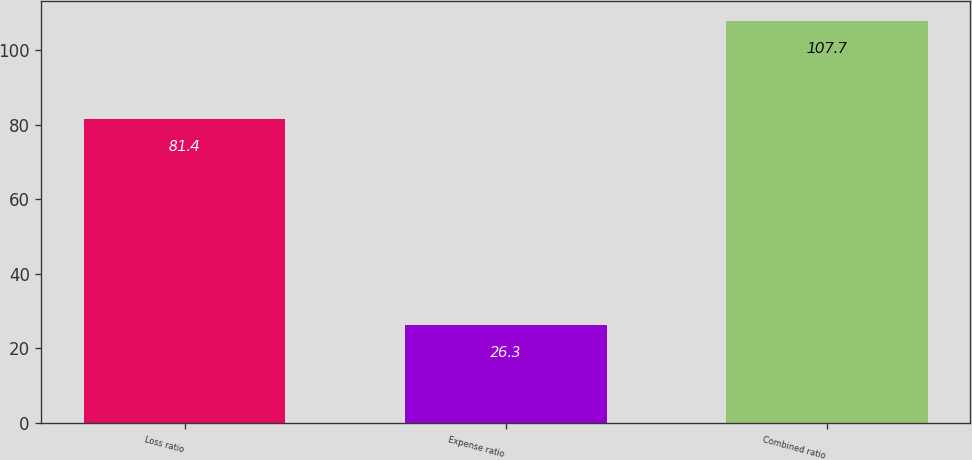Convert chart to OTSL. <chart><loc_0><loc_0><loc_500><loc_500><bar_chart><fcel>Loss ratio<fcel>Expense ratio<fcel>Combined ratio<nl><fcel>81.4<fcel>26.3<fcel>107.7<nl></chart> 